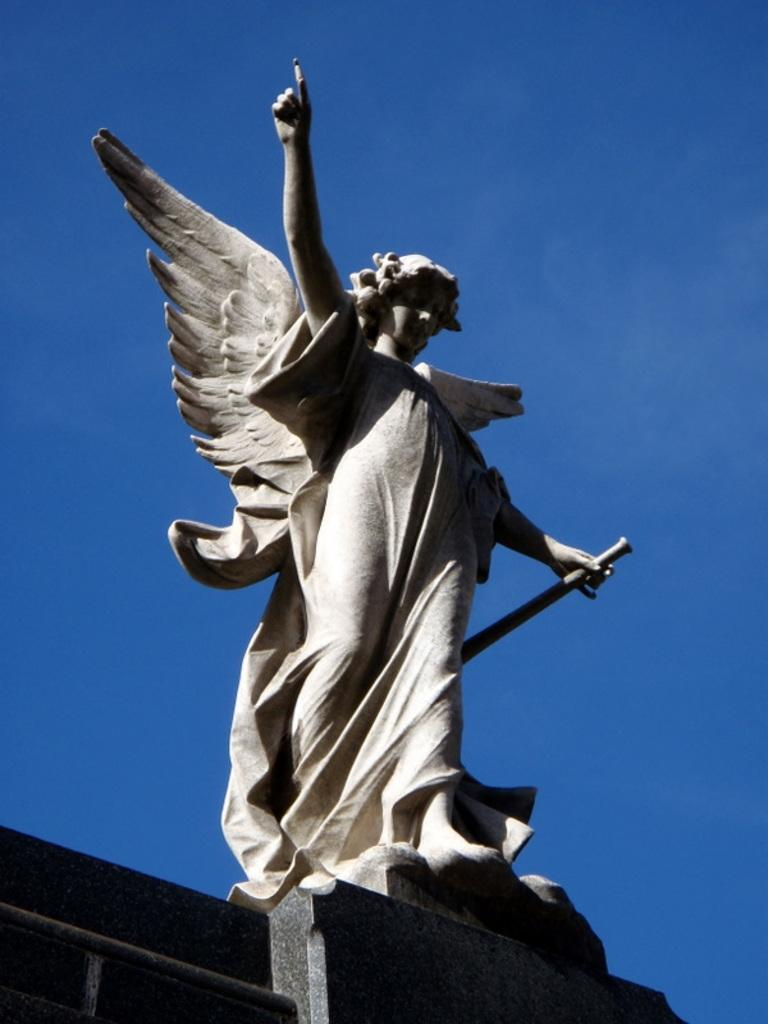What is the main subject in the center of the image? There is a statue in the center of the image. What can be seen in the background of the image? The sky is visible in the background of the image. What is located at the bottom of the image? There is a wall at the bottom of the image. What verse is the squirrel reciting in the image? There is no squirrel present in the image, and therefore no verse can be heard or seen. 